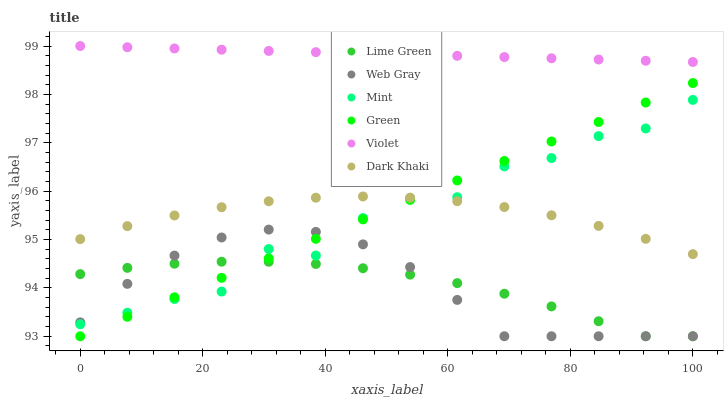Does Web Gray have the minimum area under the curve?
Answer yes or no. Yes. Does Violet have the maximum area under the curve?
Answer yes or no. Yes. Does Lime Green have the minimum area under the curve?
Answer yes or no. No. Does Lime Green have the maximum area under the curve?
Answer yes or no. No. Is Violet the smoothest?
Answer yes or no. Yes. Is Mint the roughest?
Answer yes or no. Yes. Is Lime Green the smoothest?
Answer yes or no. No. Is Lime Green the roughest?
Answer yes or no. No. Does Web Gray have the lowest value?
Answer yes or no. Yes. Does Dark Khaki have the lowest value?
Answer yes or no. No. Does Violet have the highest value?
Answer yes or no. Yes. Does Dark Khaki have the highest value?
Answer yes or no. No. Is Mint less than Violet?
Answer yes or no. Yes. Is Violet greater than Green?
Answer yes or no. Yes. Does Lime Green intersect Green?
Answer yes or no. Yes. Is Lime Green less than Green?
Answer yes or no. No. Is Lime Green greater than Green?
Answer yes or no. No. Does Mint intersect Violet?
Answer yes or no. No. 